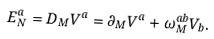<formula> <loc_0><loc_0><loc_500><loc_500>E _ { N } ^ { a } = D _ { M } V ^ { a } = \partial _ { M } V ^ { a } + \omega _ { M } ^ { a b } V _ { b } .</formula> 